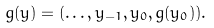<formula> <loc_0><loc_0><loc_500><loc_500>g ( y ) & = ( \dots , y _ { - 1 } , y _ { 0 } , g ( y _ { 0 } ) ) .</formula> 